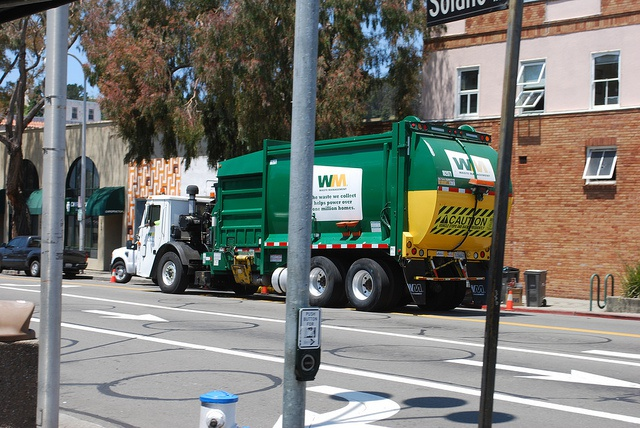Describe the objects in this image and their specific colors. I can see truck in black, teal, white, and darkgreen tones, car in black, blue, and gray tones, and fire hydrant in black, darkgray, lightgray, blue, and lightblue tones in this image. 